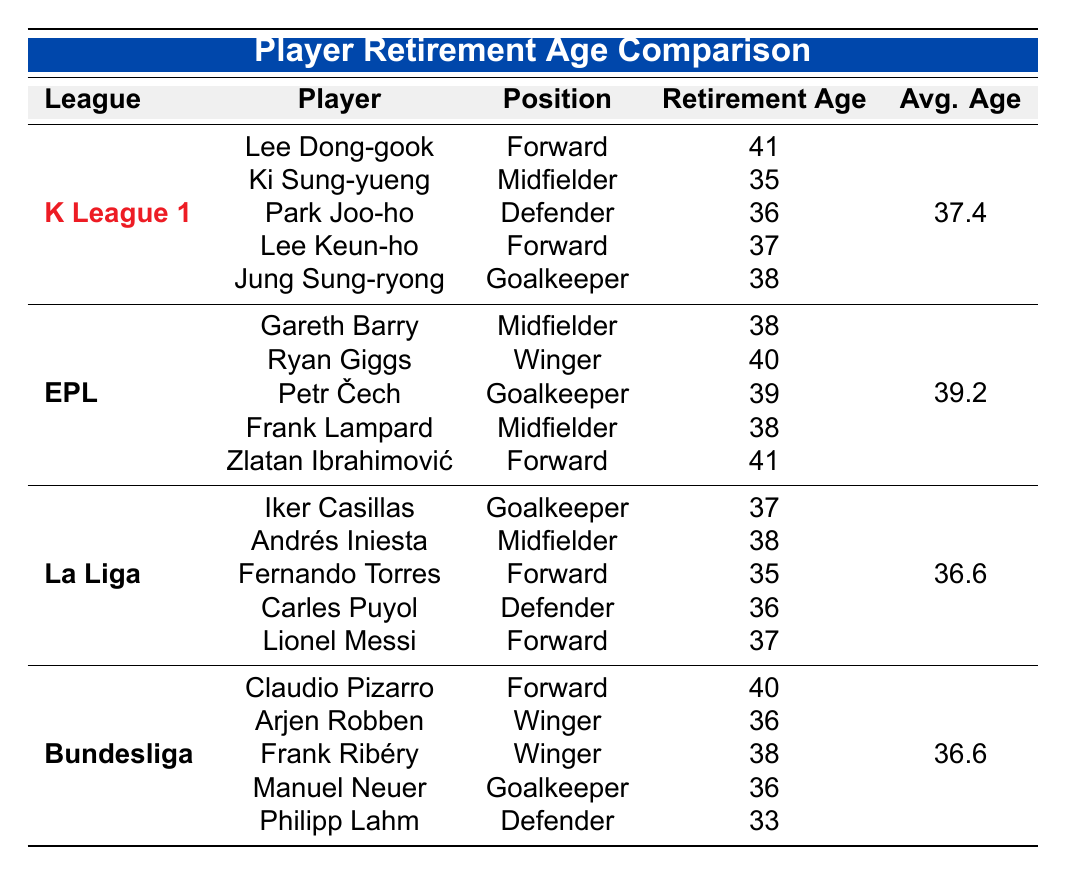What is the average retirement age of players in K League 1? The average retirement age is provided directly in the table, which lists it as 37.4 years for K League 1 players.
Answer: 37.4 Who is the oldest player in K League 1? By reviewing the retirement ages of players in K League 1, Lee Dong-gook has the highest retirement age at 41.
Answer: Lee Dong-gook How many players in the Bundesliga retired at age 36 or older? The Bundesliga has five players listed, and four of them (Claudio Pizarro, Frank Ribéry, Arjen Robben, and Manuel Neuer) retired at age 36 or older. The fifth player, Philipp Lahm, retired at 33.
Answer: 4 Is the average retirement age in La Liga higher than that in K League 1? The average retirement age in La Liga is 36.6 years, while in K League 1 it is 37.4 years. Since 37.4 is greater than 36.6, the average retirement age in La Liga is not higher.
Answer: No What is the difference in average retirement age between the English Premier League and K League 1? The average retirement age for the English Premier League is 39.2 years and for K League 1 is 37.4 years. The difference is calculated as 39.2 - 37.4 = 1.8 years.
Answer: 1.8 Which league has the youngest average retirement age, and what is it? The table provides the average retirement ages for all leagues: K League 1 (37.4), EPL (39.2), La Liga (36.6), and Bundesliga (36.6). The youngest average retirement age is shared between La Liga and Bundesliga, both at 36.6 years.
Answer: La Liga and Bundesliga, 36.6 Is it true that no player in K League 1 retired at age 35? Reviewing the data, Ki Sung-yueng retired at age 35 in K League 1. Therefore, the statement is false.
Answer: No How many forwards in the English Premier League have a retirement age of 41? In the English Premier League, there are two forwards listed (Zlatan Ibrahimović and Ryan Giggs), and only Zlatan Ibrahimović retired at age 41.
Answer: 1 